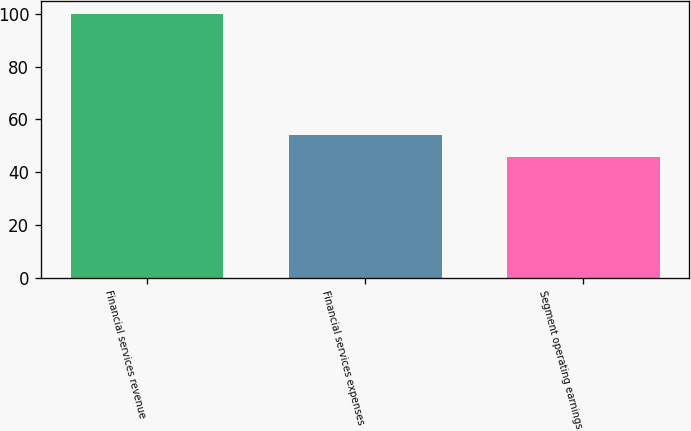Convert chart. <chart><loc_0><loc_0><loc_500><loc_500><bar_chart><fcel>Financial services revenue<fcel>Financial services expenses<fcel>Segment operating earnings<nl><fcel>100<fcel>54.2<fcel>45.8<nl></chart> 